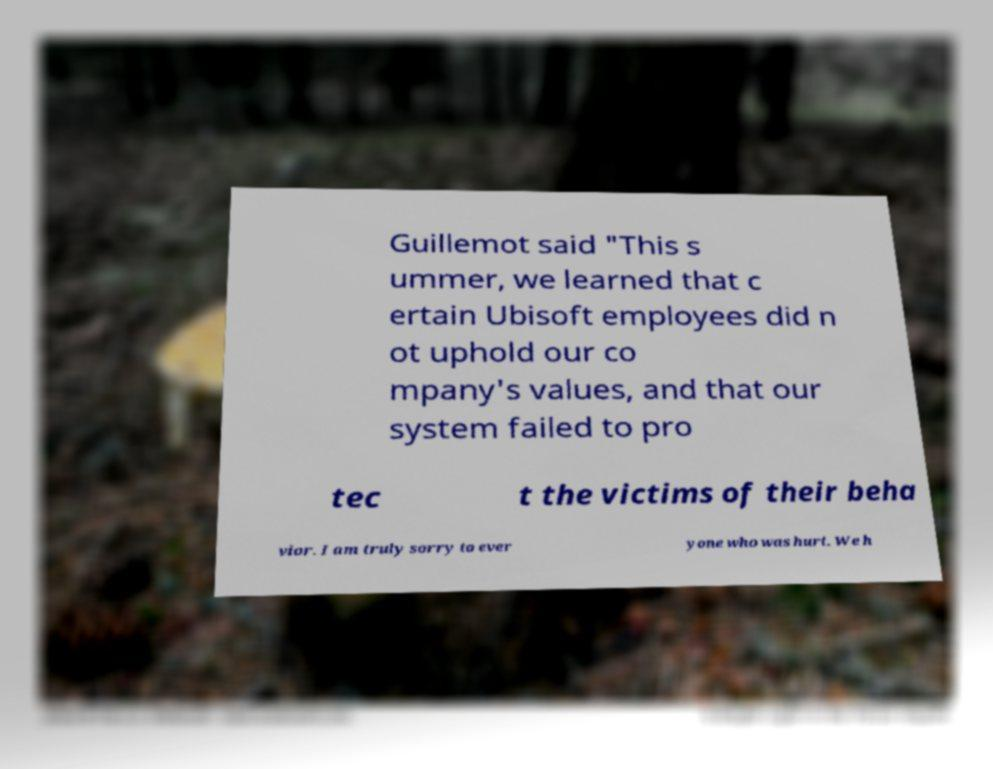Could you assist in decoding the text presented in this image and type it out clearly? Guillemot said "This s ummer, we learned that c ertain Ubisoft employees did n ot uphold our co mpany's values, and that our system failed to pro tec t the victims of their beha vior. I am truly sorry to ever yone who was hurt. We h 